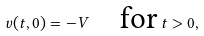Convert formula to latex. <formula><loc_0><loc_0><loc_500><loc_500>v ( t , 0 ) = - V \quad \text {for} \, t > 0 ,</formula> 